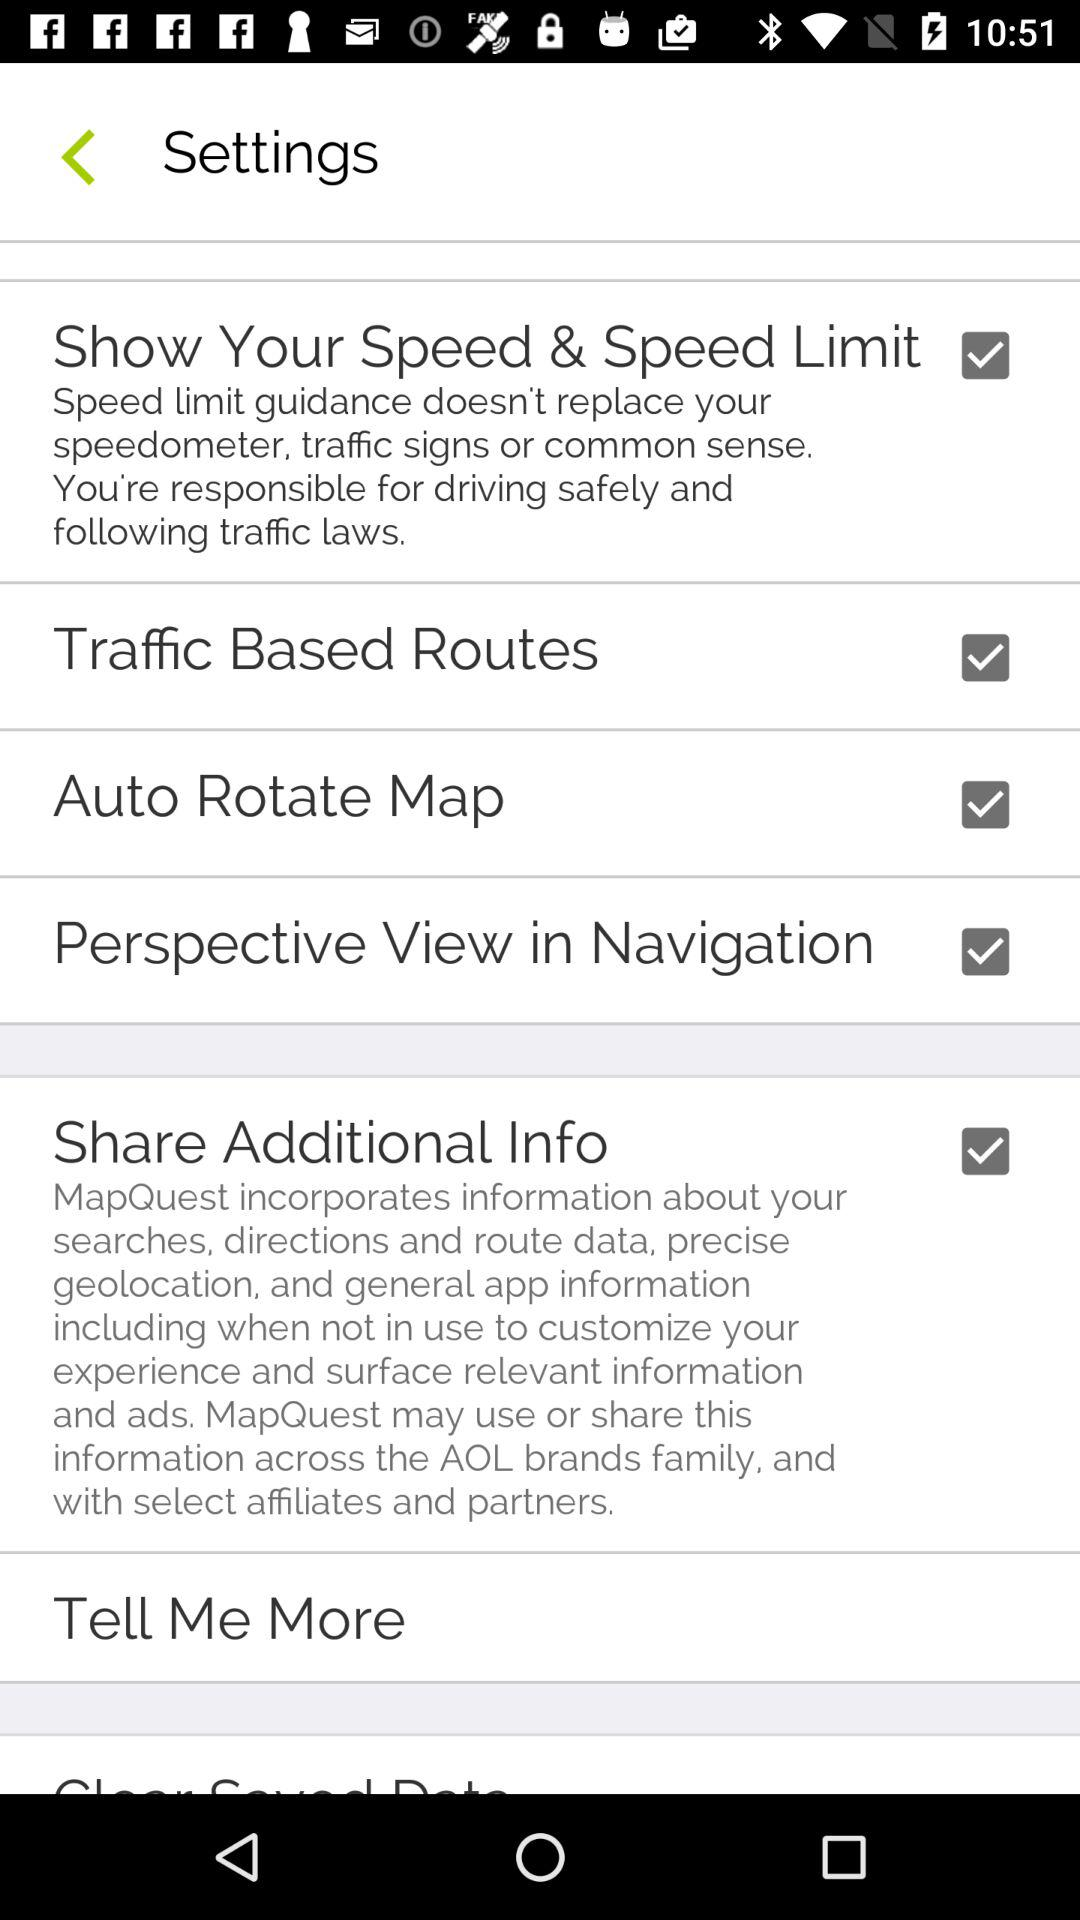How many settings checkboxes are there?
Answer the question using a single word or phrase. 5 